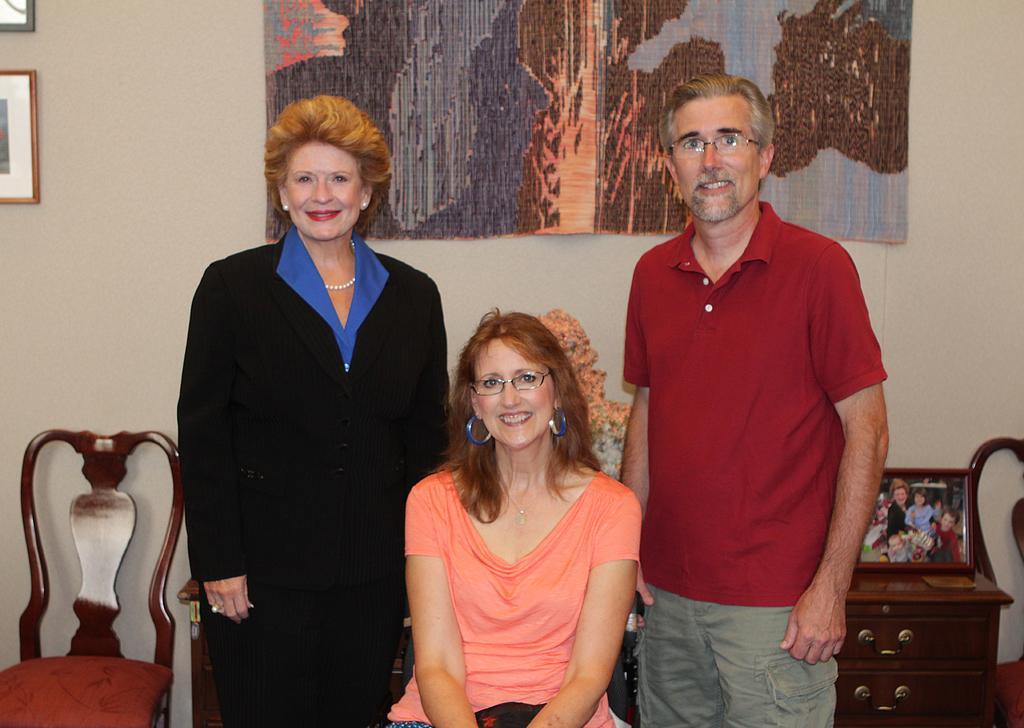Please provide a concise description of this image. In this picture we can see three persons in the middle. This is chair and there is a wall. These are the frames. Here we can see a cupboard. And there is a flower vase. 